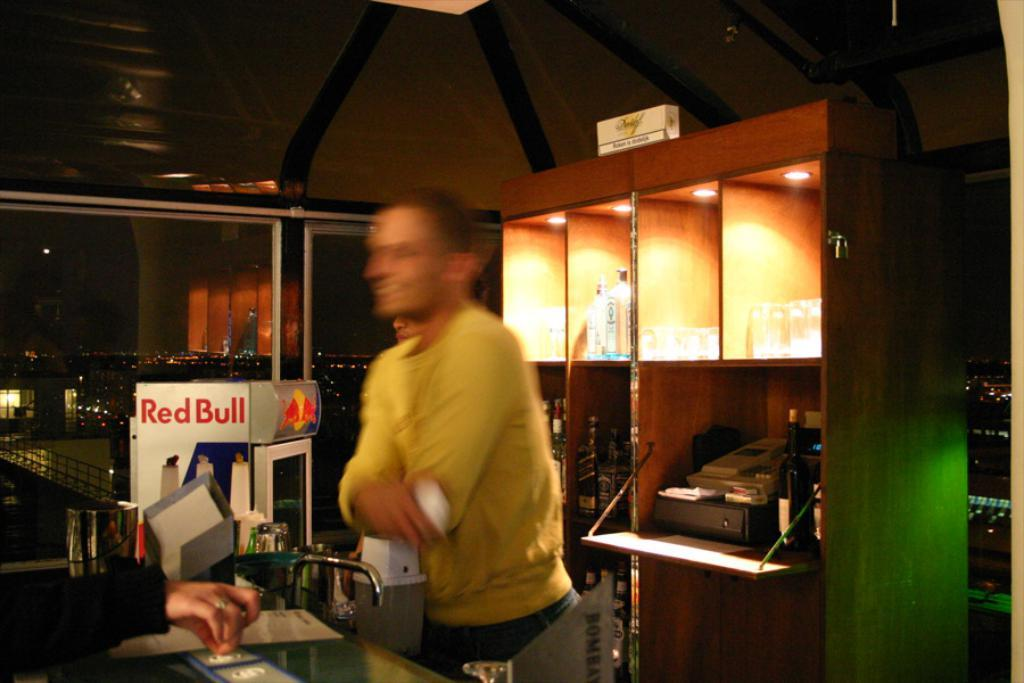<image>
Give a short and clear explanation of the subsequent image. A person in a yellow shirt stands beside a container that says Red Bull. 